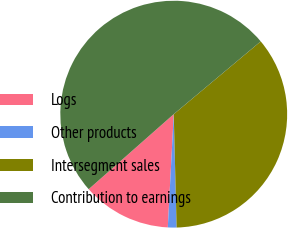Convert chart to OTSL. <chart><loc_0><loc_0><loc_500><loc_500><pie_chart><fcel>Logs<fcel>Other products<fcel>Intersegment sales<fcel>Contribution to earnings<nl><fcel>12.66%<fcel>1.24%<fcel>35.68%<fcel>50.41%<nl></chart> 